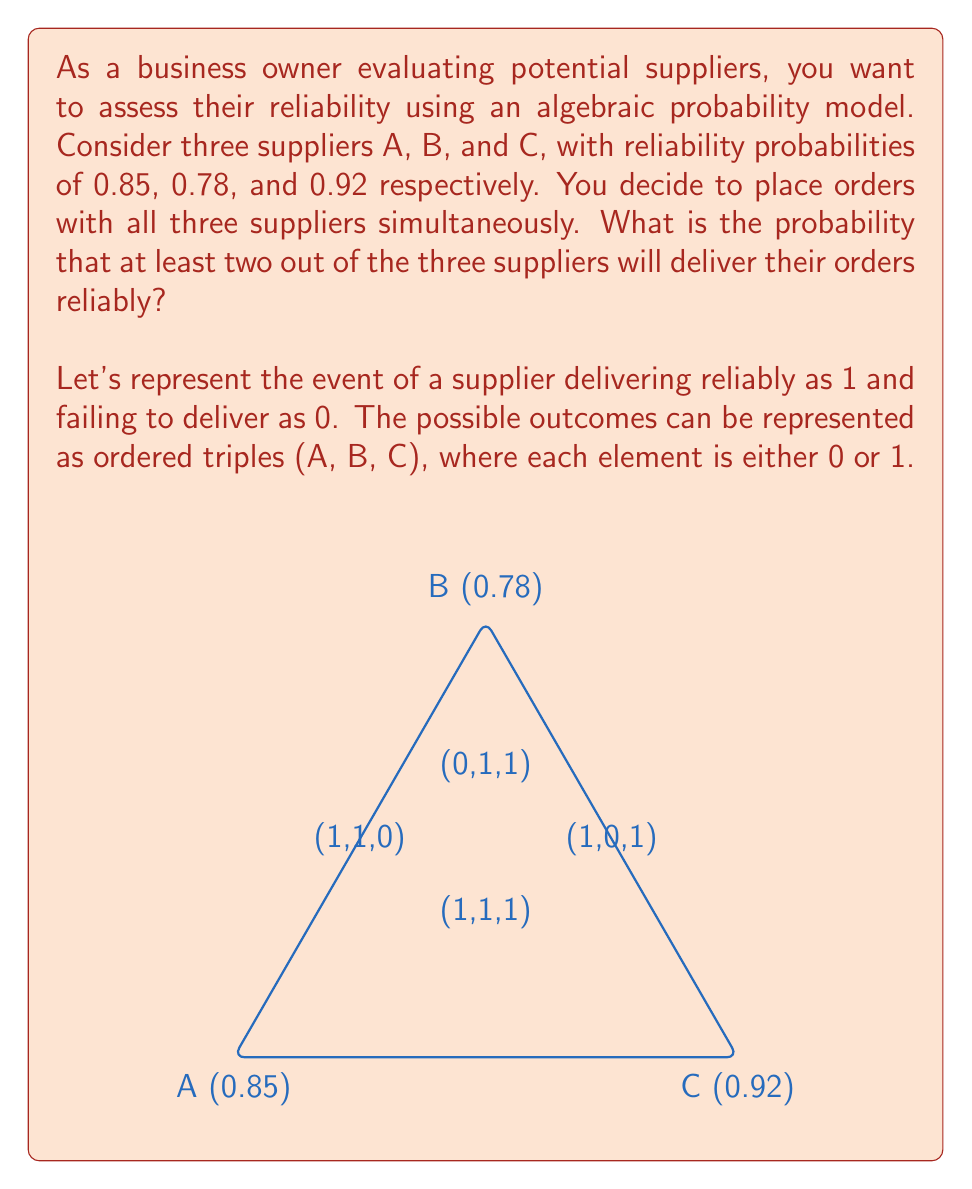Could you help me with this problem? Let's approach this step-by-step:

1) First, we need to find the probability of at least two suppliers delivering reliably. This is equivalent to the probability of all three delivering reliably, plus the probability of exactly two delivering reliably.

2) Let's define our events:
   A: Supplier A delivers reliably
   B: Supplier B delivers reliably
   C: Supplier C delivers reliably

3) Probability of all three delivering reliably:
   $P(A \cap B \cap C) = 0.85 \times 0.78 \times 0.92 = 0.6089$

4) Probability of exactly two delivering reliably:
   There are three possible scenarios:
   a) A and B deliver, C fails: $P(A \cap B \cap \bar{C}) = 0.85 \times 0.78 \times (1-0.92) = 0.0530$
   b) A and C deliver, B fails: $P(A \cap \bar{B} \cap C) = 0.85 \times (1-0.78) \times 0.92 = 0.1722$
   c) B and C deliver, A fails: $P(\bar{A} \cap B \cap C) = (1-0.85) \times 0.78 \times 0.92 = 0.1078$

5) Sum the probabilities of exactly two delivering:
   $P(\text{exactly two}) = 0.0530 + 0.1722 + 0.1078 = 0.3330$

6) Finally, add this to the probability of all three delivering:
   $P(\text{at least two}) = P(\text{all three}) + P(\text{exactly two})$
   $= 0.6089 + 0.3330 = 0.9419$

Therefore, the probability that at least two out of the three suppliers will deliver their orders reliably is 0.9419 or about 94.19%.
Answer: 0.9419 